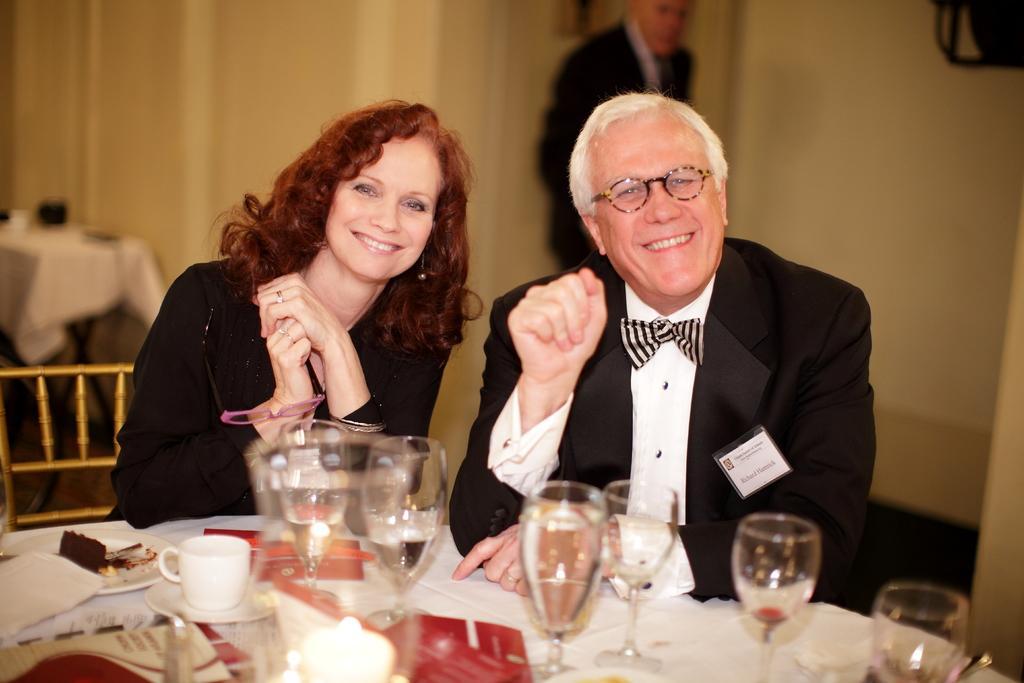Describe this image in one or two sentences. A man is sitting on the chair, he wore a black color coat and smiling. Beside him there is a woman, she wore a black color dress and also smiling. there are wine glasses on this dining table. 